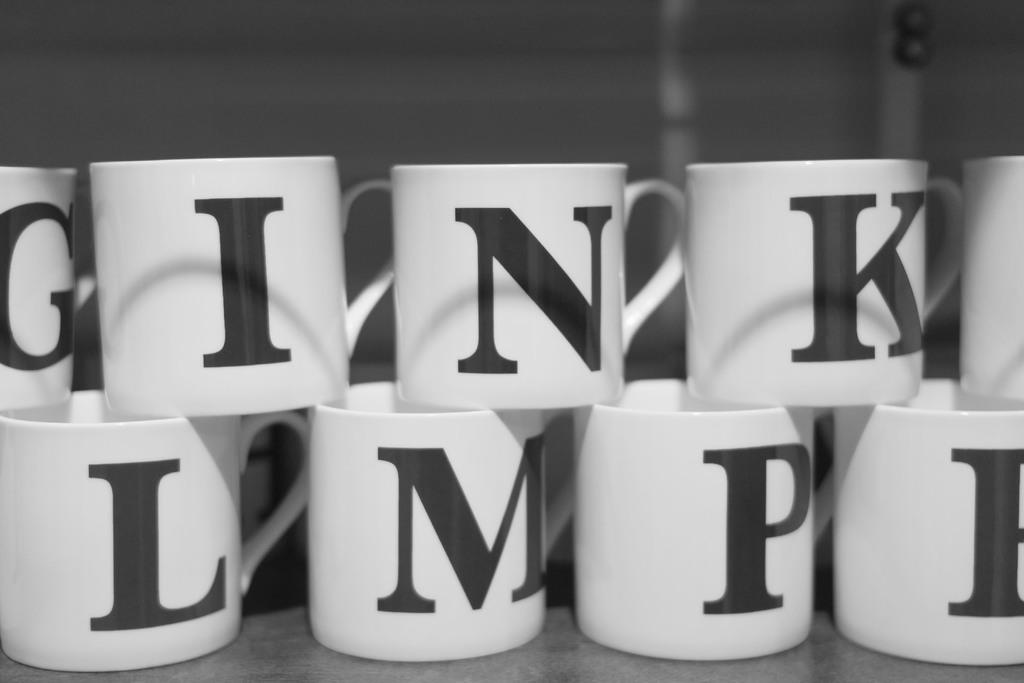Provide a one-sentence caption for the provided image. White mugs are stacked together, each bearing a different letter of the alphabet in black. 